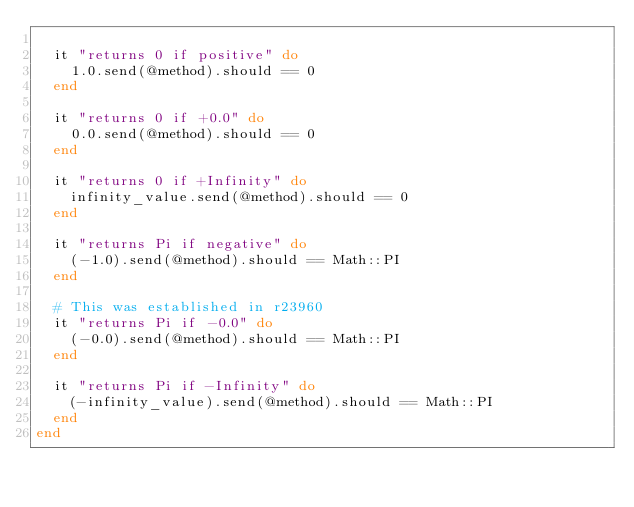<code> <loc_0><loc_0><loc_500><loc_500><_Ruby_>
  it "returns 0 if positive" do
    1.0.send(@method).should == 0
  end

  it "returns 0 if +0.0" do
    0.0.send(@method).should == 0
  end

  it "returns 0 if +Infinity" do
    infinity_value.send(@method).should == 0
  end

  it "returns Pi if negative" do
    (-1.0).send(@method).should == Math::PI
  end

  # This was established in r23960
  it "returns Pi if -0.0" do
    (-0.0).send(@method).should == Math::PI
  end

  it "returns Pi if -Infinity" do
    (-infinity_value).send(@method).should == Math::PI
  end
end
</code> 